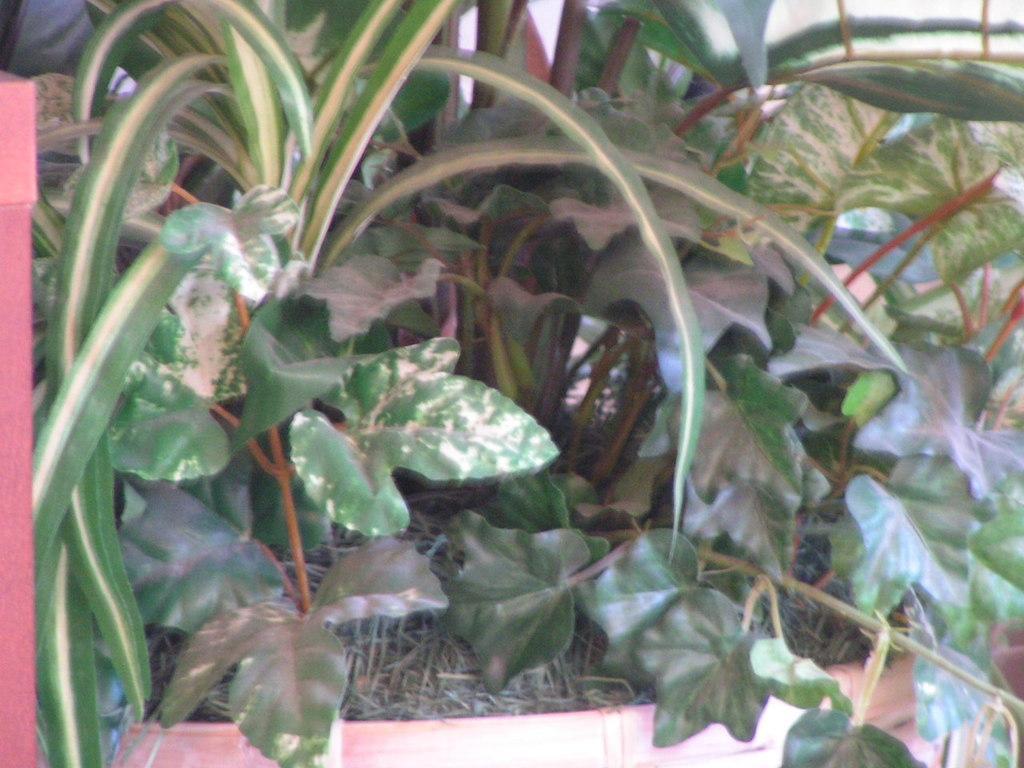Describe this image in one or two sentences. At the bottom of this image, there are plants. In the background, there are some objects. 